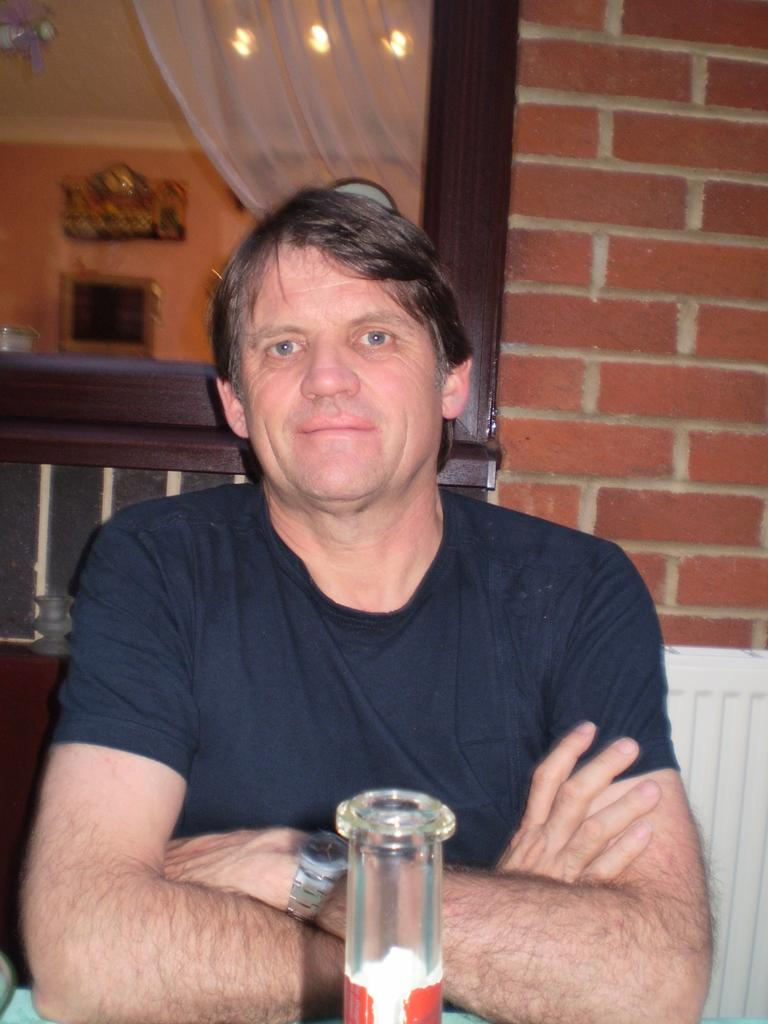Who is present in the image? There is a man in the image. What is the man doing in the image? The man is sitting at a table. Where is the table located? The table is in a restaurant. Is the man sinking into quicksand in the image? No, there is no quicksand present in the image. The man is sitting at a table in a restaurant. 